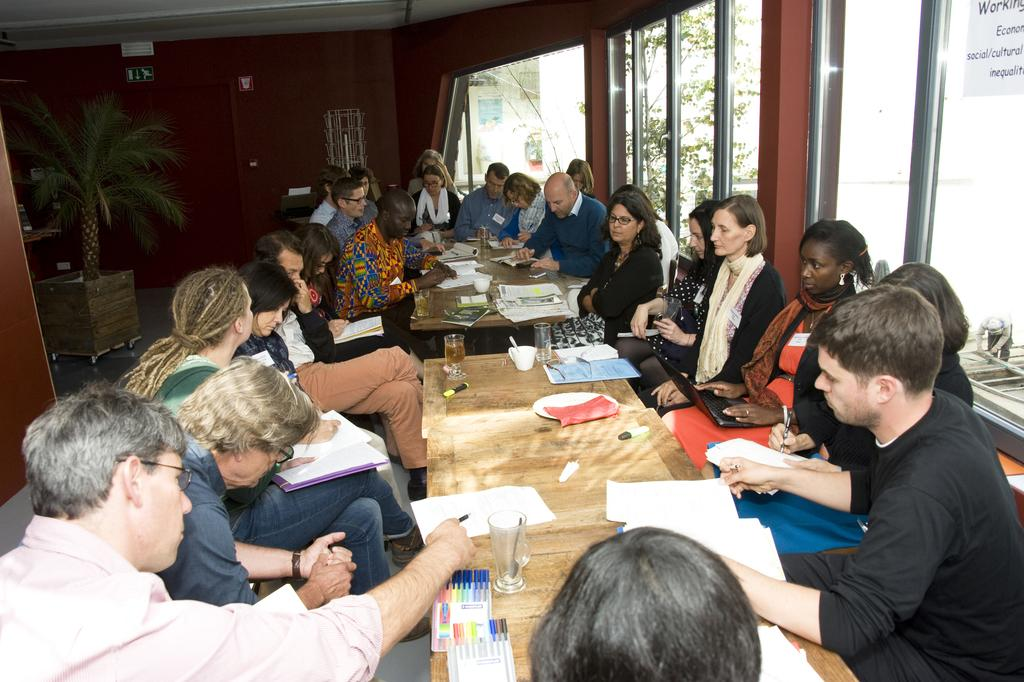What are the people in the image doing? The people in the image are sitting. What objects can be seen on the table in the image? There are pens, papers, and glasses on the table in the image. Can you describe the background of the image? There is a plant in the background of the image. Is there a rat sleeping on the coil in the image? There is no rat or coil present in the image. 